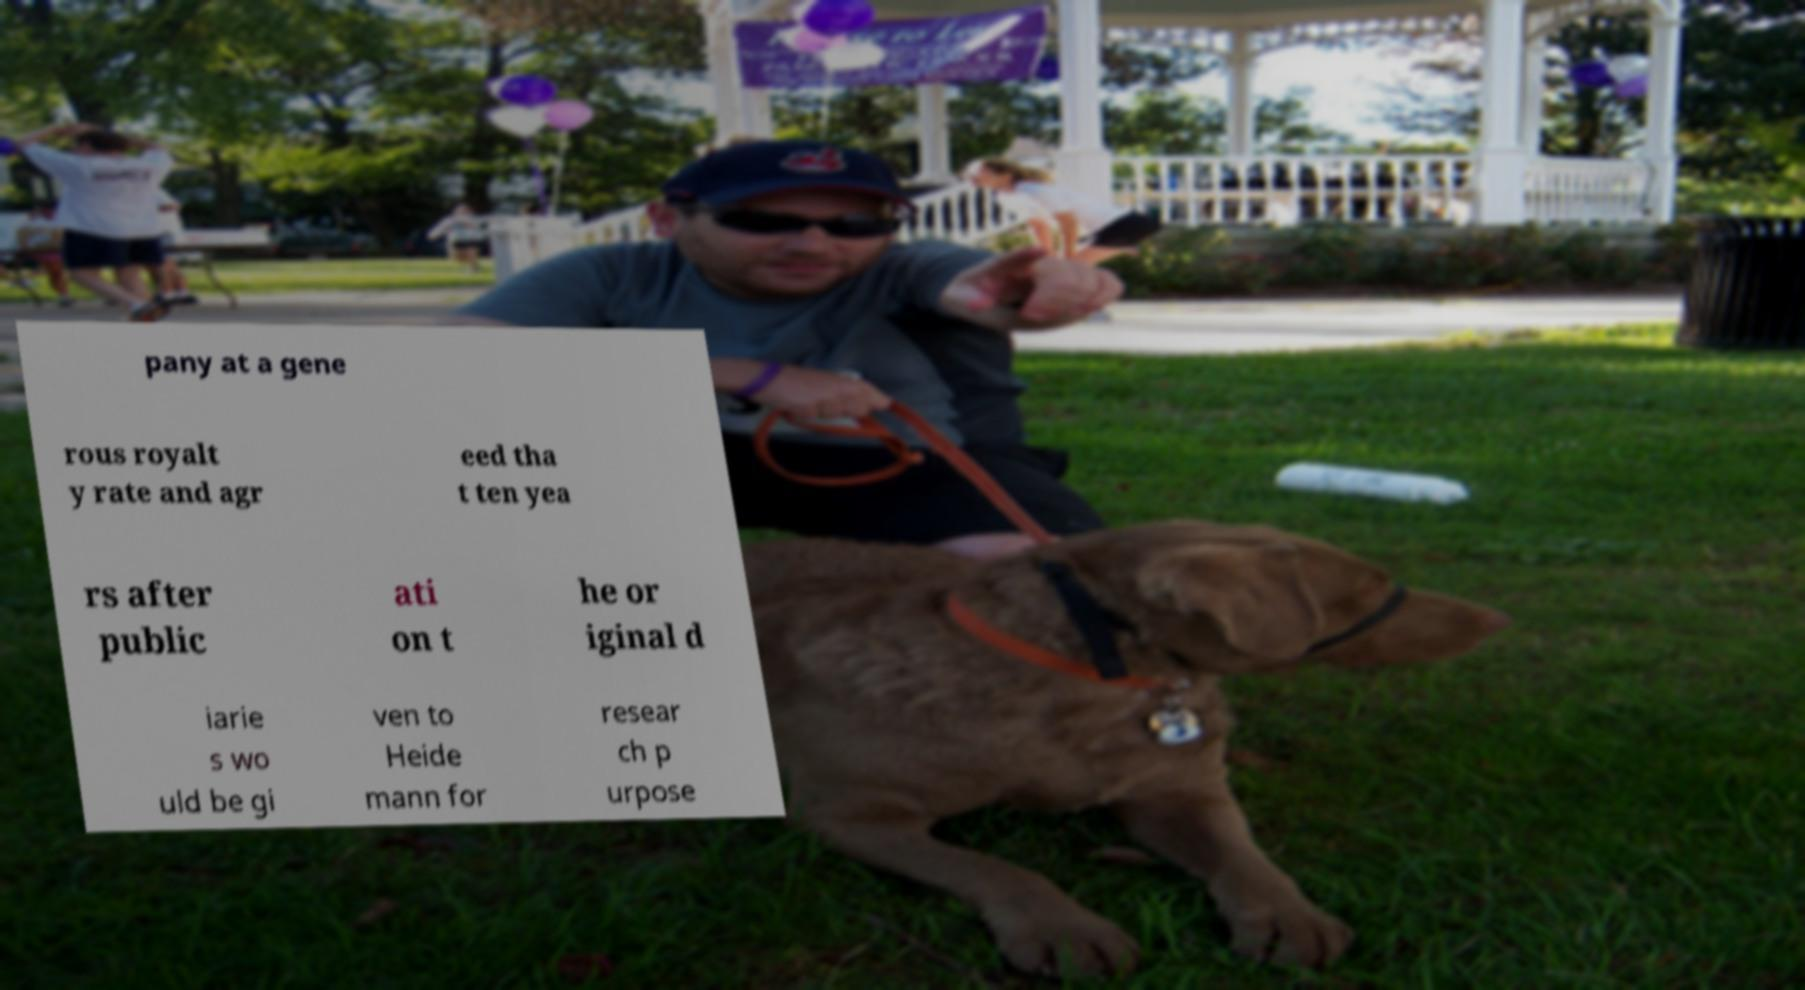Could you assist in decoding the text presented in this image and type it out clearly? pany at a gene rous royalt y rate and agr eed tha t ten yea rs after public ati on t he or iginal d iarie s wo uld be gi ven to Heide mann for resear ch p urpose 